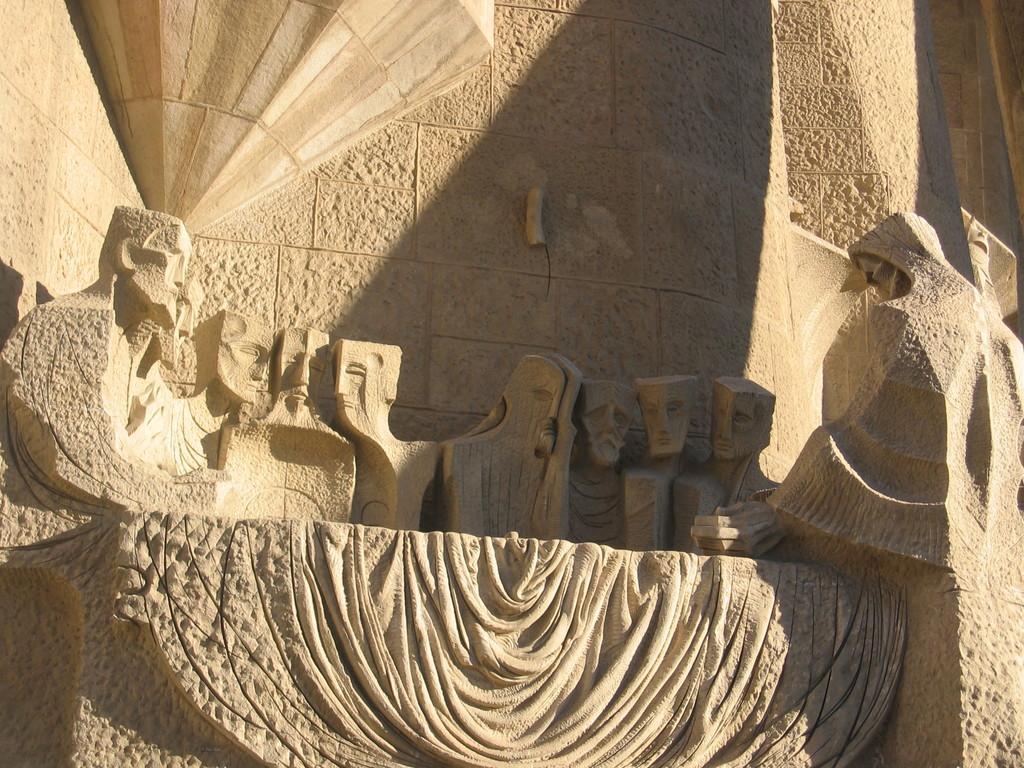Can you describe this image briefly? Here we can see sculptures and wall. 